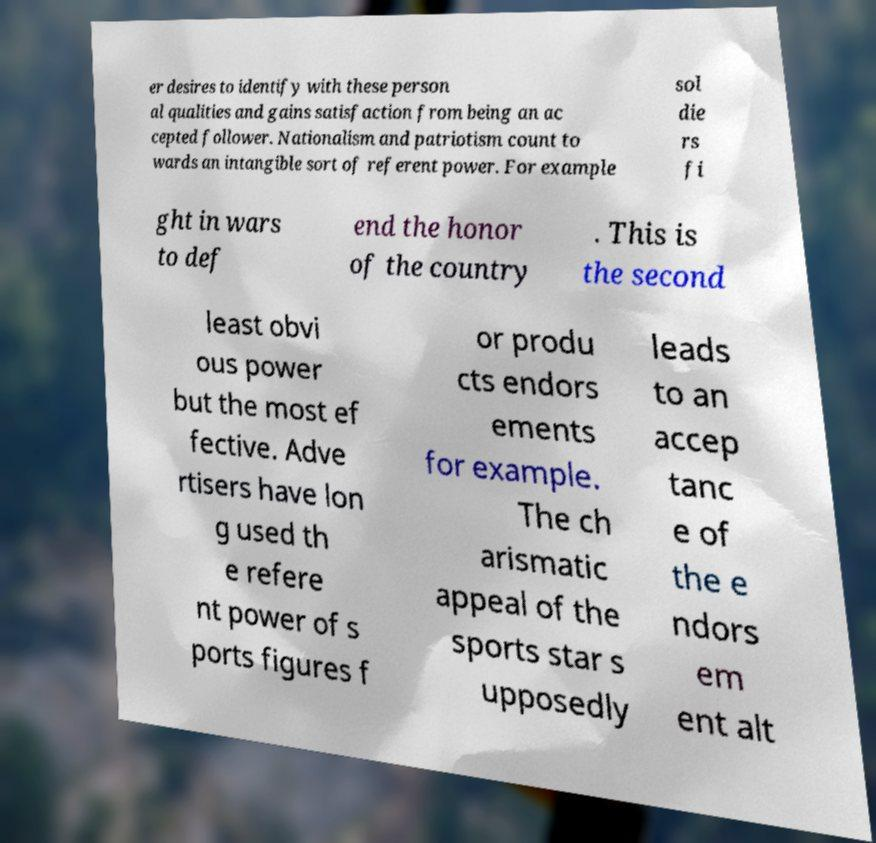For documentation purposes, I need the text within this image transcribed. Could you provide that? er desires to identify with these person al qualities and gains satisfaction from being an ac cepted follower. Nationalism and patriotism count to wards an intangible sort of referent power. For example sol die rs fi ght in wars to def end the honor of the country . This is the second least obvi ous power but the most ef fective. Adve rtisers have lon g used th e refere nt power of s ports figures f or produ cts endors ements for example. The ch arismatic appeal of the sports star s upposedly leads to an accep tanc e of the e ndors em ent alt 